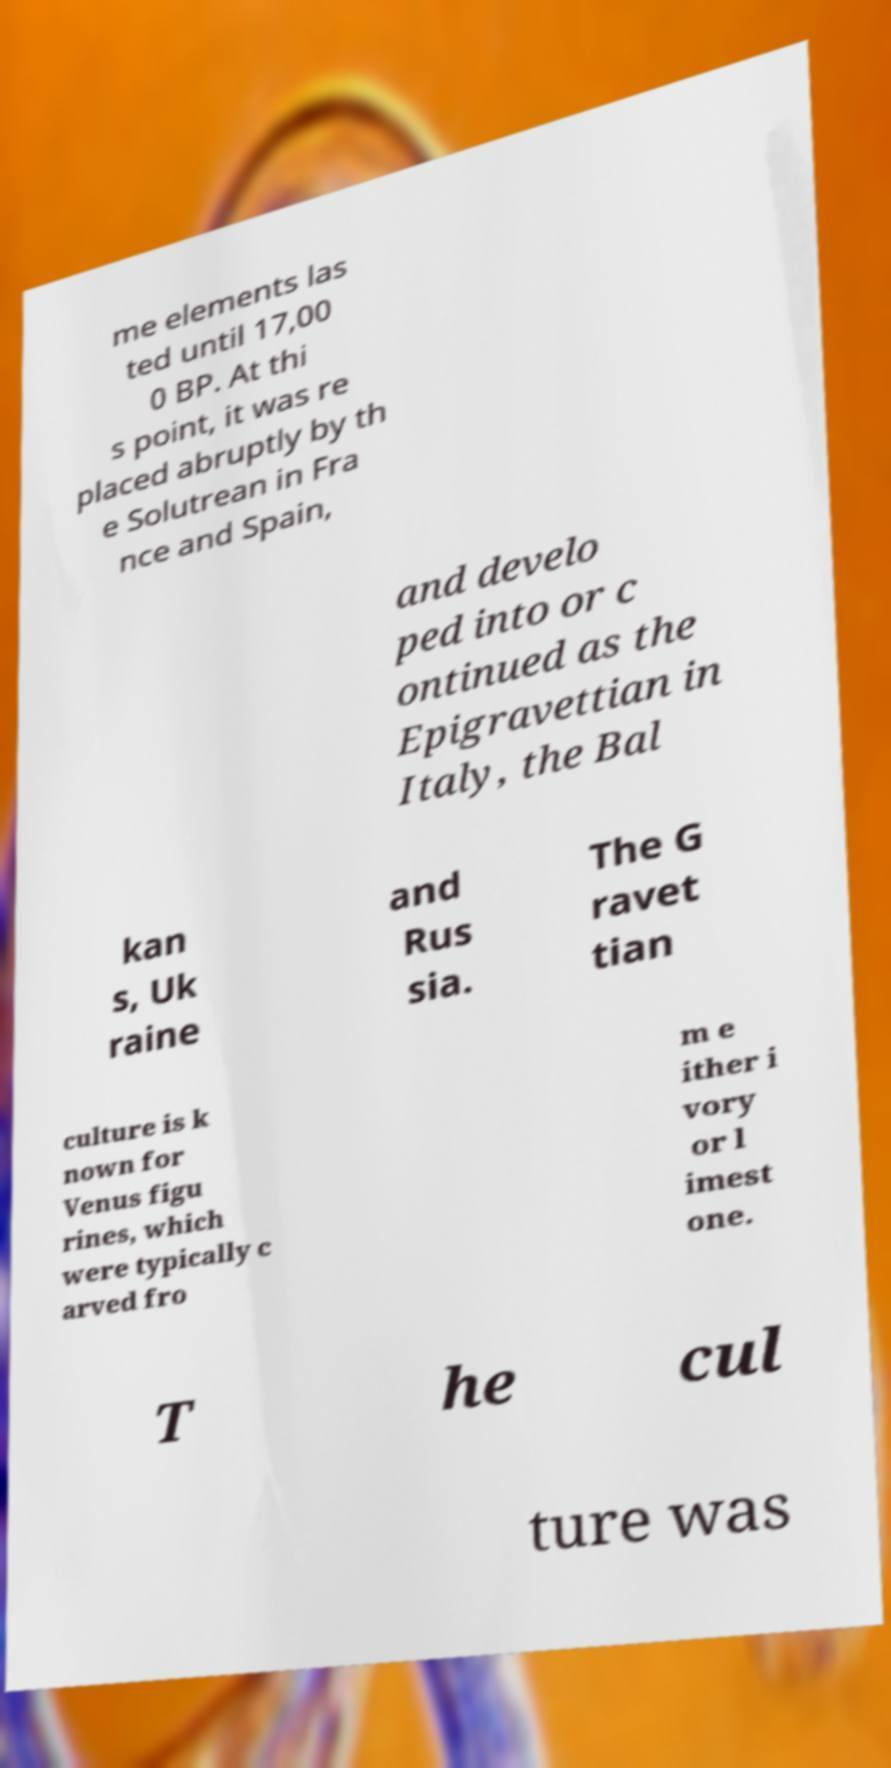Can you read and provide the text displayed in the image?This photo seems to have some interesting text. Can you extract and type it out for me? me elements las ted until 17,00 0 BP. At thi s point, it was re placed abruptly by th e Solutrean in Fra nce and Spain, and develo ped into or c ontinued as the Epigravettian in Italy, the Bal kan s, Uk raine and Rus sia. The G ravet tian culture is k nown for Venus figu rines, which were typically c arved fro m e ither i vory or l imest one. T he cul ture was 